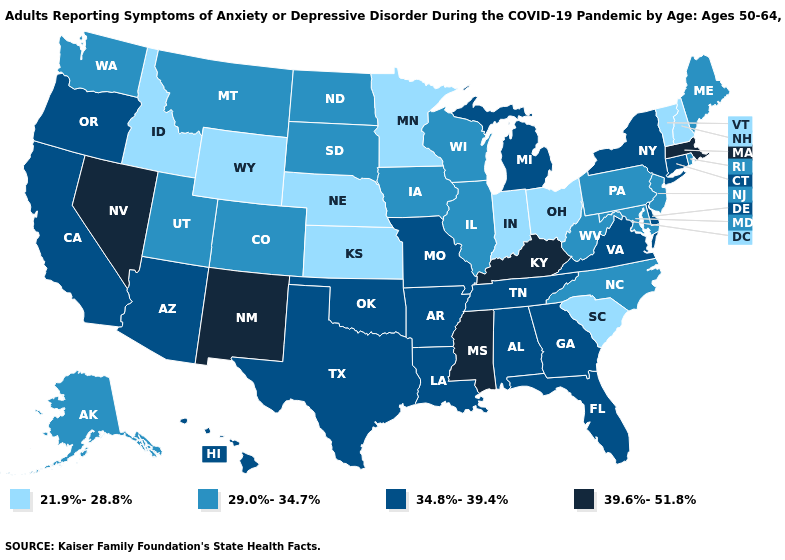Does Florida have the highest value in the South?
Short answer required. No. Does Massachusetts have a lower value than Michigan?
Keep it brief. No. Name the states that have a value in the range 21.9%-28.8%?
Keep it brief. Idaho, Indiana, Kansas, Minnesota, Nebraska, New Hampshire, Ohio, South Carolina, Vermont, Wyoming. Which states have the highest value in the USA?
Concise answer only. Kentucky, Massachusetts, Mississippi, Nevada, New Mexico. Name the states that have a value in the range 29.0%-34.7%?
Write a very short answer. Alaska, Colorado, Illinois, Iowa, Maine, Maryland, Montana, New Jersey, North Carolina, North Dakota, Pennsylvania, Rhode Island, South Dakota, Utah, Washington, West Virginia, Wisconsin. Which states have the lowest value in the USA?
Quick response, please. Idaho, Indiana, Kansas, Minnesota, Nebraska, New Hampshire, Ohio, South Carolina, Vermont, Wyoming. Does New Mexico have a higher value than Rhode Island?
Quick response, please. Yes. Does Alabama have the lowest value in the USA?
Short answer required. No. Name the states that have a value in the range 29.0%-34.7%?
Short answer required. Alaska, Colorado, Illinois, Iowa, Maine, Maryland, Montana, New Jersey, North Carolina, North Dakota, Pennsylvania, Rhode Island, South Dakota, Utah, Washington, West Virginia, Wisconsin. Does the first symbol in the legend represent the smallest category?
Short answer required. Yes. What is the value of Hawaii?
Concise answer only. 34.8%-39.4%. Name the states that have a value in the range 29.0%-34.7%?
Concise answer only. Alaska, Colorado, Illinois, Iowa, Maine, Maryland, Montana, New Jersey, North Carolina, North Dakota, Pennsylvania, Rhode Island, South Dakota, Utah, Washington, West Virginia, Wisconsin. What is the lowest value in the USA?
Short answer required. 21.9%-28.8%. Does Nebraska have the lowest value in the USA?
Short answer required. Yes. What is the value of California?
Quick response, please. 34.8%-39.4%. 